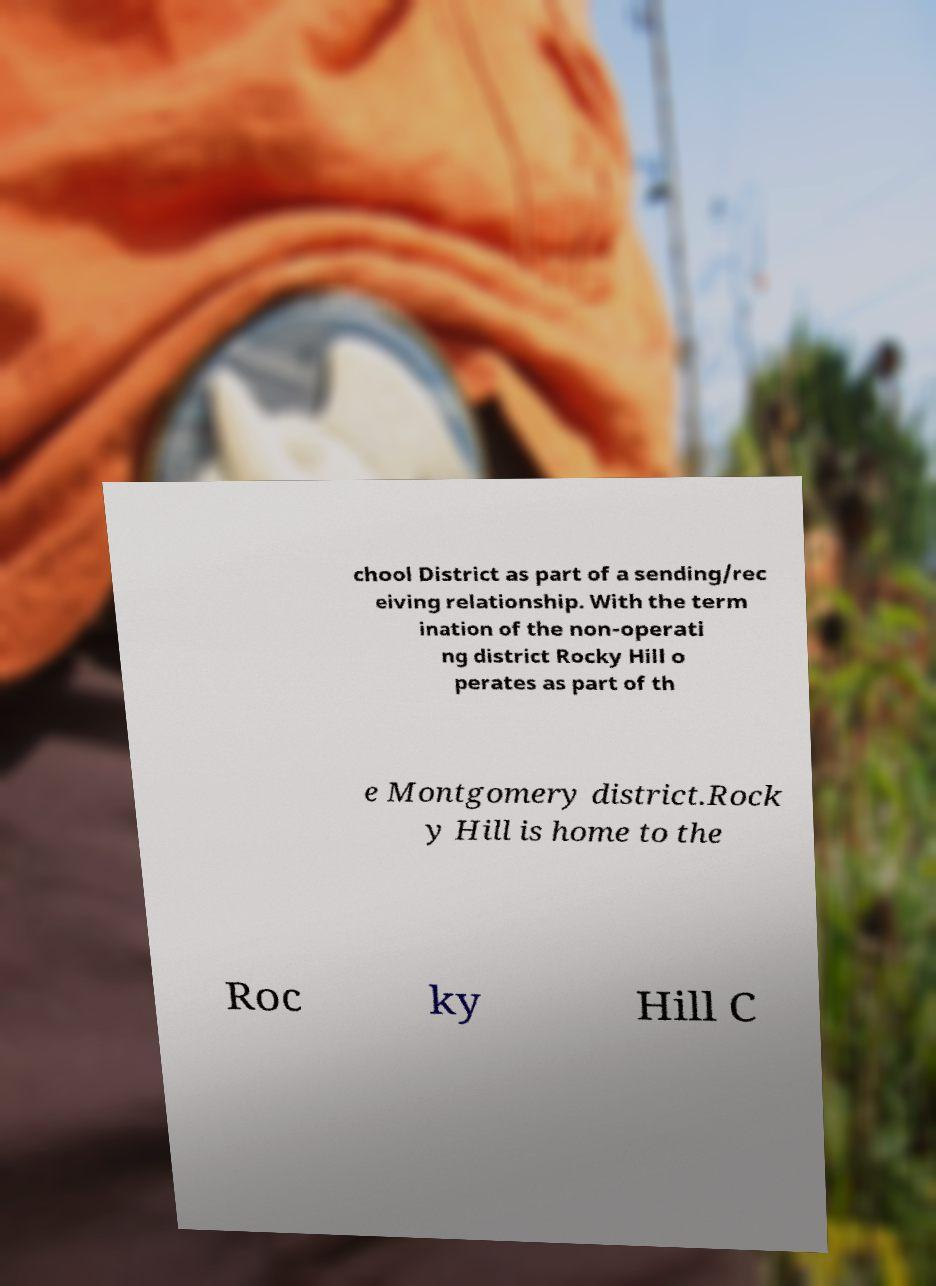Can you accurately transcribe the text from the provided image for me? chool District as part of a sending/rec eiving relationship. With the term ination of the non-operati ng district Rocky Hill o perates as part of th e Montgomery district.Rock y Hill is home to the Roc ky Hill C 